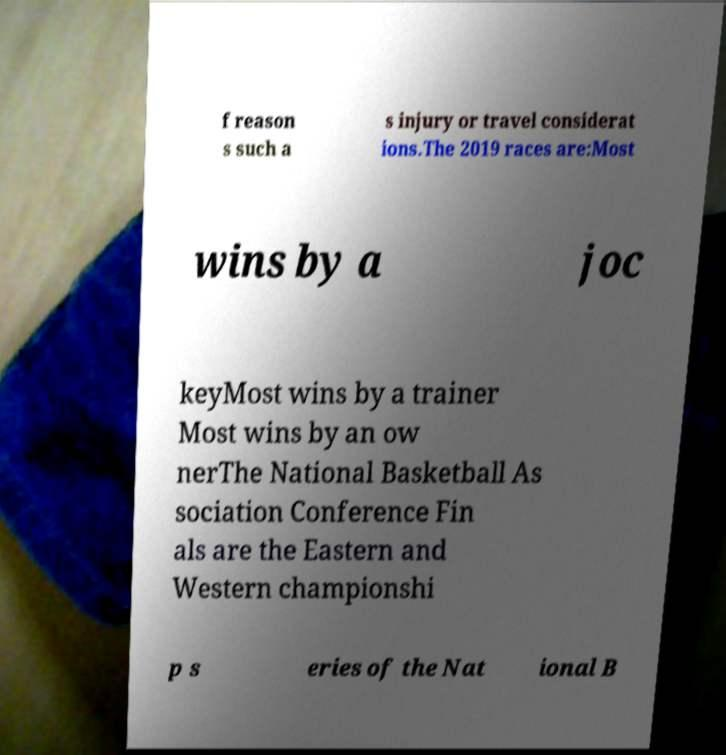Please identify and transcribe the text found in this image. f reason s such a s injury or travel considerat ions.The 2019 races are:Most wins by a joc keyMost wins by a trainer Most wins by an ow nerThe National Basketball As sociation Conference Fin als are the Eastern and Western championshi p s eries of the Nat ional B 